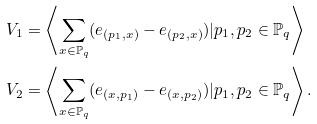Convert formula to latex. <formula><loc_0><loc_0><loc_500><loc_500>V _ { 1 } & = \left \langle \sum _ { x \in \mathbb { P } _ { q } } ( e _ { ( p _ { 1 } , x ) } - e _ { ( p _ { 2 } , x ) } ) | p _ { 1 } , p _ { 2 } \in \mathbb { P } _ { q } \right \rangle \\ V _ { 2 } & = \left \langle \sum _ { x \in \mathbb { P } _ { q } } ( e _ { ( x , p _ { 1 } ) } - e _ { ( x , p _ { 2 } ) } ) | p _ { 1 } , p _ { 2 } \in \mathbb { P } _ { q } \right \rangle .</formula> 